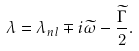<formula> <loc_0><loc_0><loc_500><loc_500>\lambda = \lambda _ { n l } \mp i \widetilde { \omega } - \frac { \widetilde { \Gamma } } 2 .</formula> 